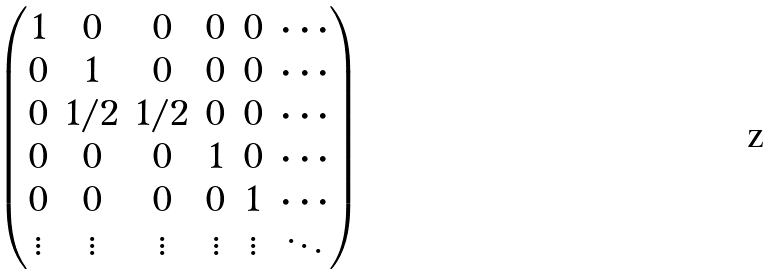Convert formula to latex. <formula><loc_0><loc_0><loc_500><loc_500>\begin{pmatrix} 1 & 0 & 0 & 0 & 0 & \cdots \\ 0 & 1 & 0 & 0 & 0 & \cdots \\ 0 & 1 / 2 & 1 / 2 & 0 & 0 & \cdots \\ 0 & 0 & 0 & 1 & 0 & \cdots \\ 0 & 0 & 0 & 0 & 1 & \cdots \\ \vdots & \vdots & \vdots & \vdots & \vdots & \ddots \end{pmatrix}</formula> 